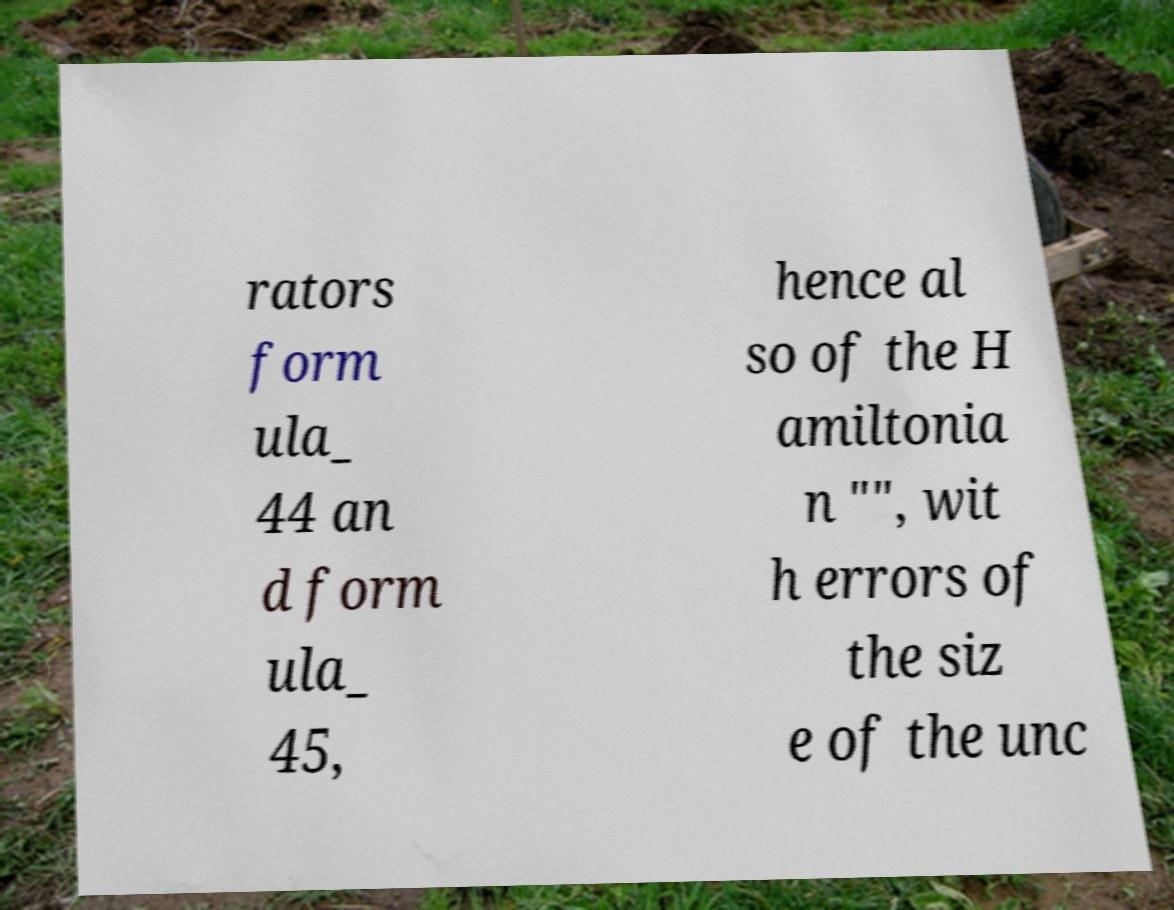Please identify and transcribe the text found in this image. rators form ula_ 44 an d form ula_ 45, hence al so of the H amiltonia n "", wit h errors of the siz e of the unc 